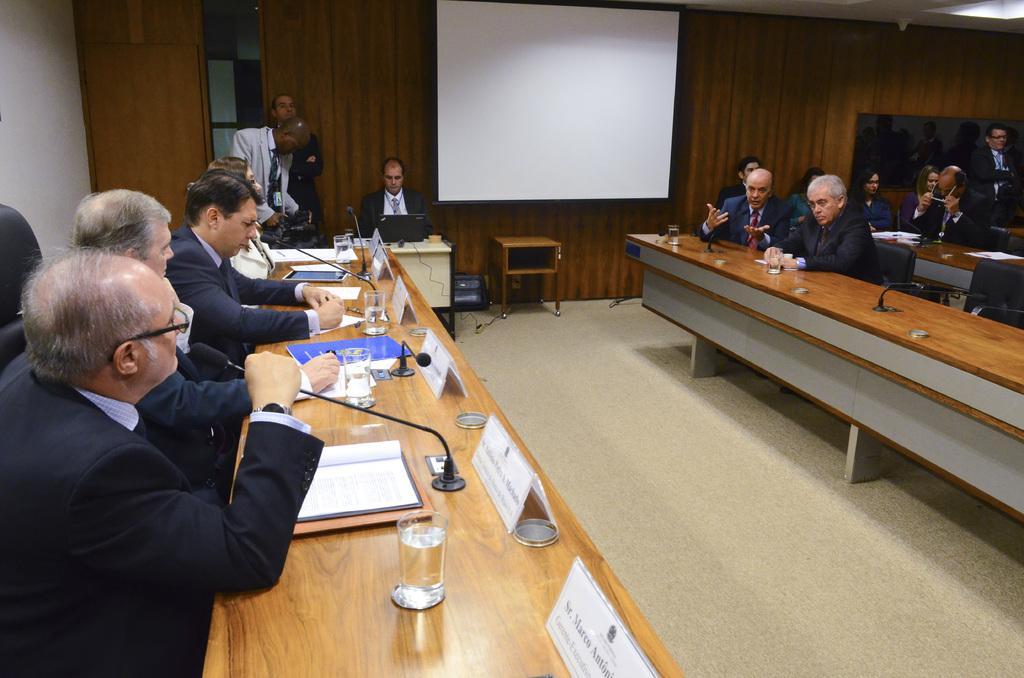In one or two sentences, can you explain what this image depicts? Here we can see group of people sitting on chairs in front of a table in a conference room and here we can see a projector screen and on the table we can see a glass of water and papers present with name card on each place 